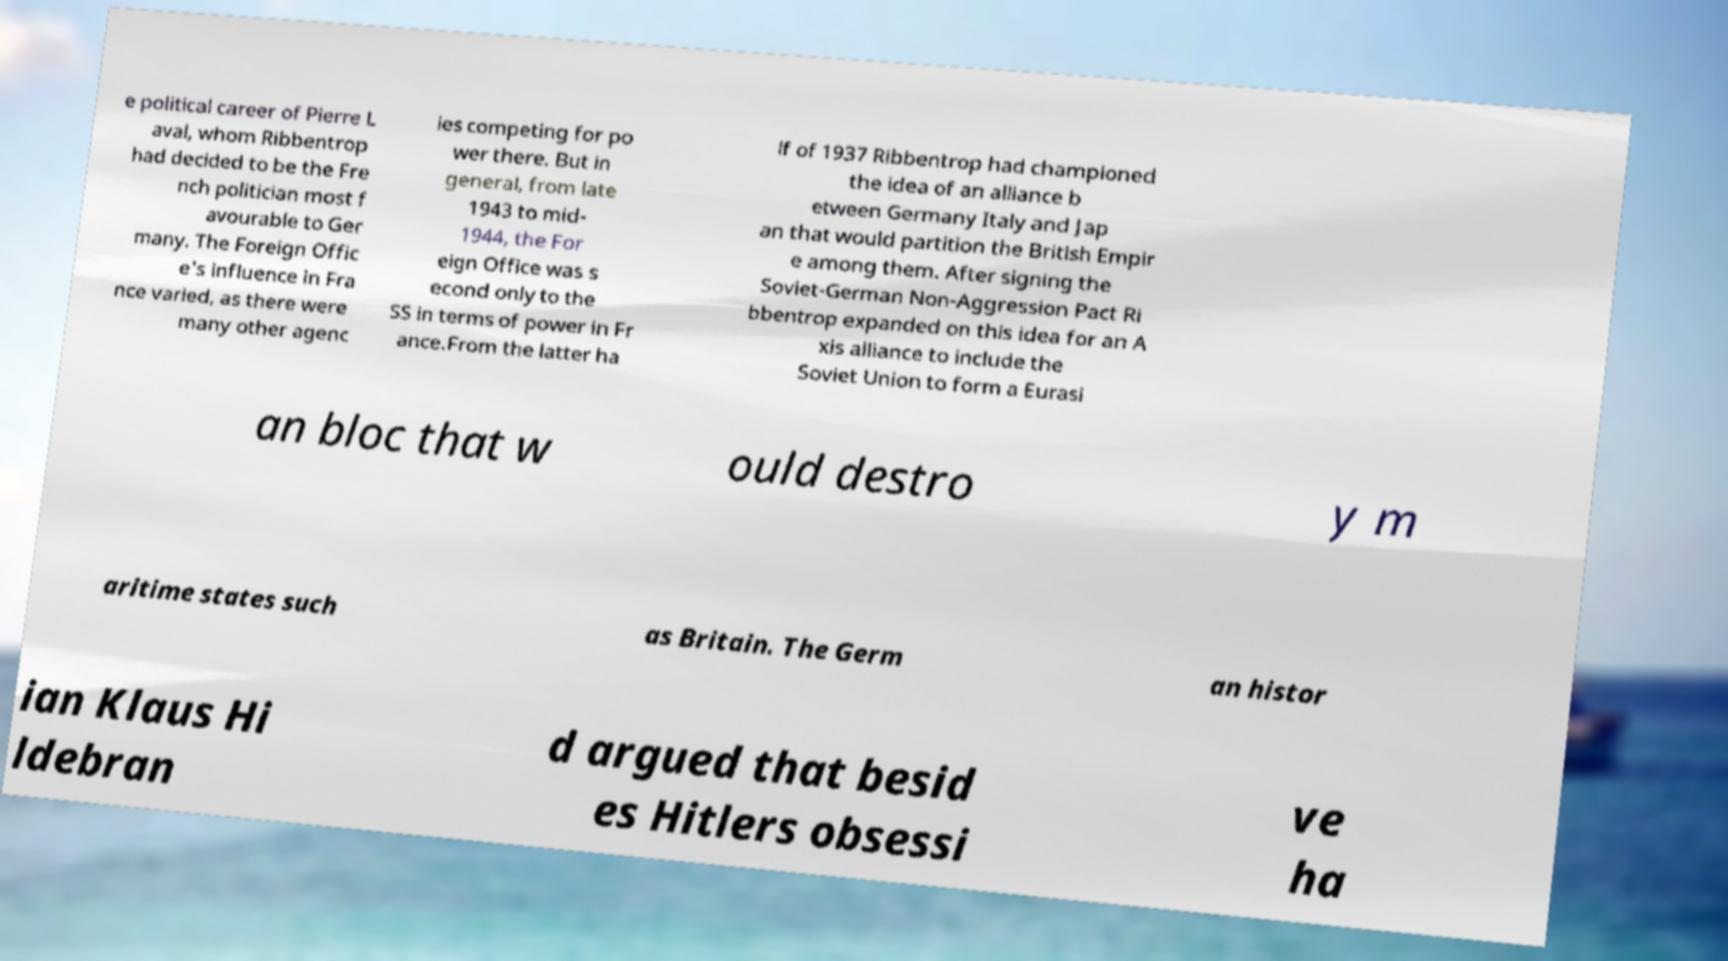Could you extract and type out the text from this image? e political career of Pierre L aval, whom Ribbentrop had decided to be the Fre nch politician most f avourable to Ger many. The Foreign Offic e's influence in Fra nce varied, as there were many other agenc ies competing for po wer there. But in general, from late 1943 to mid- 1944, the For eign Office was s econd only to the SS in terms of power in Fr ance.From the latter ha lf of 1937 Ribbentrop had championed the idea of an alliance b etween Germany Italy and Jap an that would partition the British Empir e among them. After signing the Soviet-German Non-Aggression Pact Ri bbentrop expanded on this idea for an A xis alliance to include the Soviet Union to form a Eurasi an bloc that w ould destro y m aritime states such as Britain. The Germ an histor ian Klaus Hi ldebran d argued that besid es Hitlers obsessi ve ha 